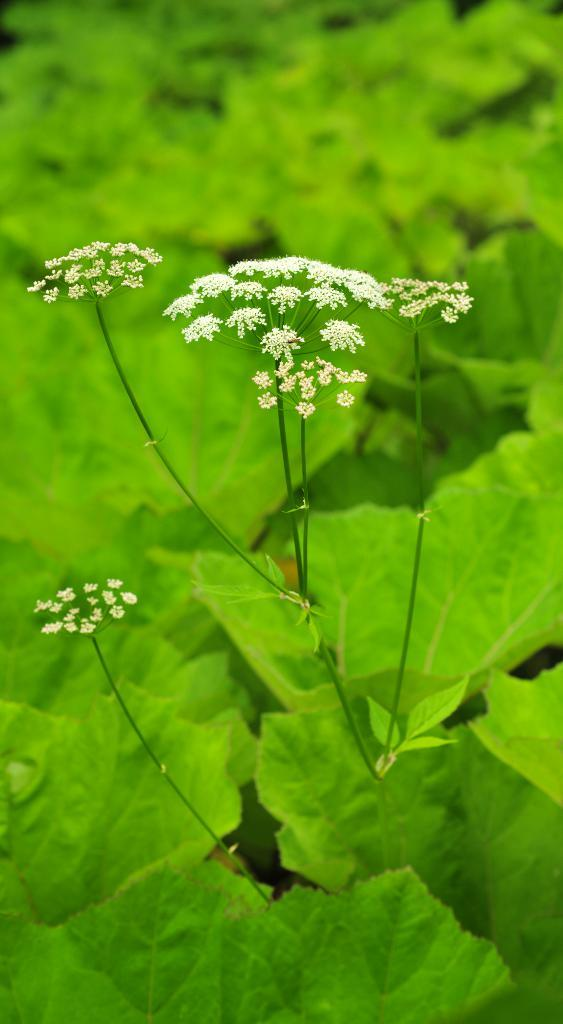What type of flora can be seen in the image? There are flowers in the image. What color are the flowers? The flowers are white in color. What color are the plants that the flowers are on? The plants are green in color. Can you describe the background of the image? The background of the image is blurry. What type of cord is used to connect the system in the image? There is no cord or system present in the image; it features flowers and plants. 